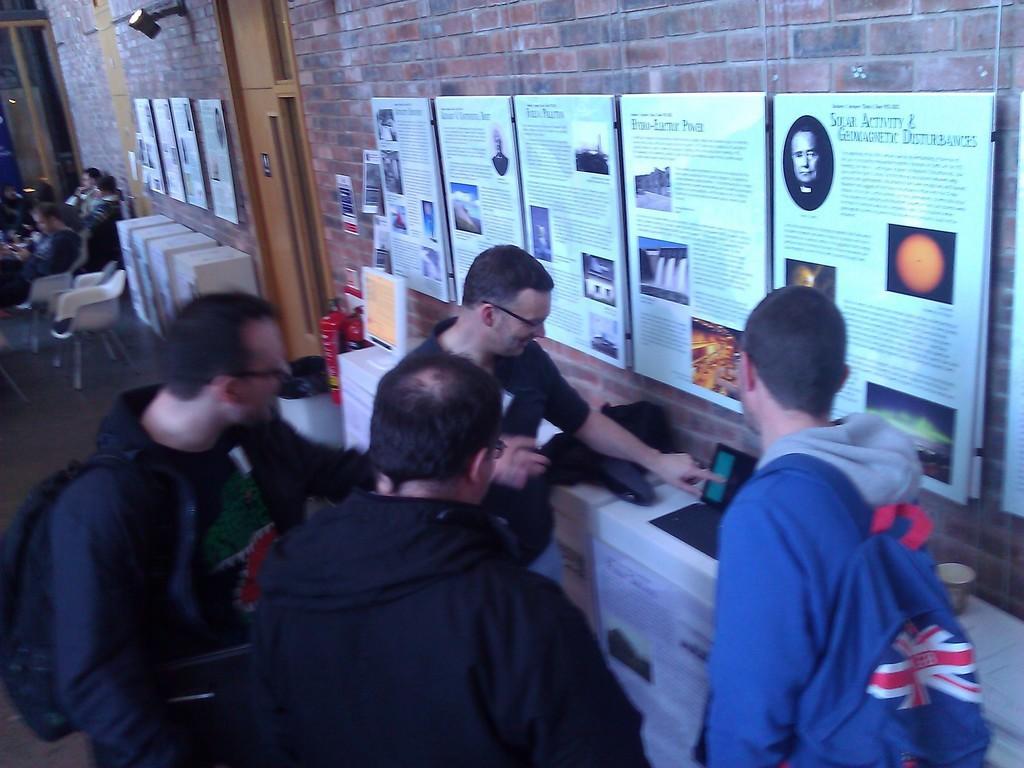How would you summarize this image in a sentence or two? There are four men standing. These are the frames attached to the wall. I can see a laptop and a bag are placed on the table. These are the fire extinguishers. This is the monitor. I can see few people sitting on the chairs. This looks like a wooden door. I think this is the dustbin. Here is the lamp attached to the wall. 